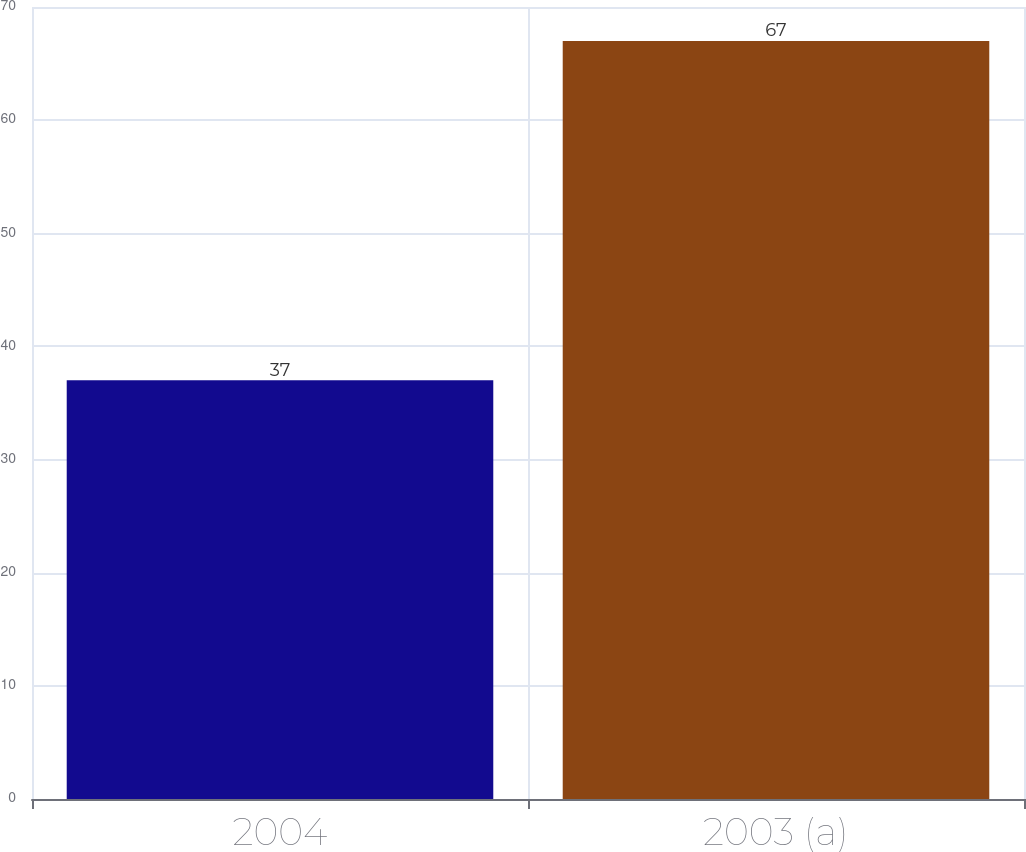<chart> <loc_0><loc_0><loc_500><loc_500><bar_chart><fcel>2004<fcel>2003 (a)<nl><fcel>37<fcel>67<nl></chart> 